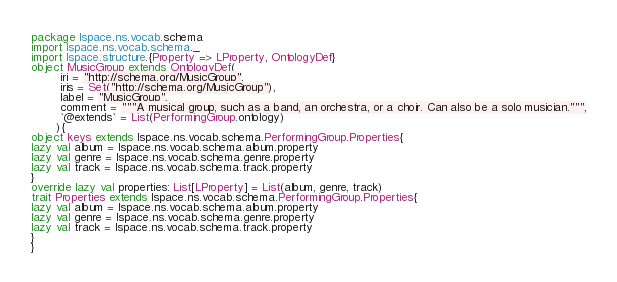Convert code to text. <code><loc_0><loc_0><loc_500><loc_500><_Scala_>package lspace.ns.vocab.schema
import lspace.ns.vocab.schema._
import lspace.structure.{Property => LProperty, OntologyDef}
object MusicGroup extends OntologyDef(
        iri = "http://schema.org/MusicGroup",
        iris = Set("http://schema.org/MusicGroup"),
        label = "MusicGroup",
        comment = """A musical group, such as a band, an orchestra, or a choir. Can also be a solo musician.""",
        `@extends` = List(PerformingGroup.ontology)
       ){
object keys extends lspace.ns.vocab.schema.PerformingGroup.Properties{
lazy val album = lspace.ns.vocab.schema.album.property
lazy val genre = lspace.ns.vocab.schema.genre.property
lazy val track = lspace.ns.vocab.schema.track.property
}
override lazy val properties: List[LProperty] = List(album, genre, track)
trait Properties extends lspace.ns.vocab.schema.PerformingGroup.Properties{
lazy val album = lspace.ns.vocab.schema.album.property
lazy val genre = lspace.ns.vocab.schema.genre.property
lazy val track = lspace.ns.vocab.schema.track.property
}
}</code> 